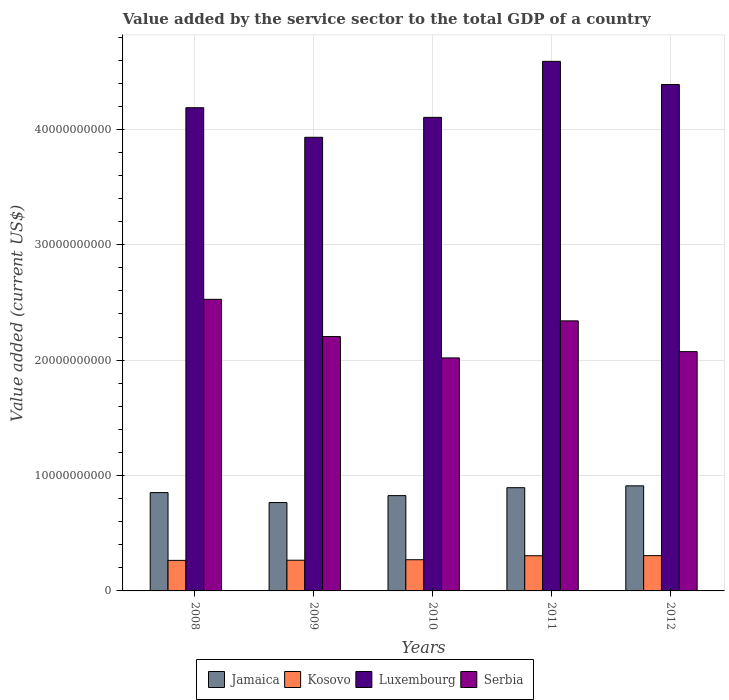How many different coloured bars are there?
Ensure brevity in your answer.  4. How many groups of bars are there?
Provide a short and direct response. 5. Are the number of bars per tick equal to the number of legend labels?
Make the answer very short. Yes. Are the number of bars on each tick of the X-axis equal?
Make the answer very short. Yes. In how many cases, is the number of bars for a given year not equal to the number of legend labels?
Provide a short and direct response. 0. What is the value added by the service sector to the total GDP in Kosovo in 2011?
Your response must be concise. 3.05e+09. Across all years, what is the maximum value added by the service sector to the total GDP in Kosovo?
Keep it short and to the point. 3.06e+09. Across all years, what is the minimum value added by the service sector to the total GDP in Serbia?
Provide a short and direct response. 2.02e+1. In which year was the value added by the service sector to the total GDP in Kosovo maximum?
Your answer should be very brief. 2012. What is the total value added by the service sector to the total GDP in Serbia in the graph?
Give a very brief answer. 1.12e+11. What is the difference between the value added by the service sector to the total GDP in Jamaica in 2009 and that in 2011?
Offer a very short reply. -1.29e+09. What is the difference between the value added by the service sector to the total GDP in Serbia in 2010 and the value added by the service sector to the total GDP in Kosovo in 2012?
Provide a succinct answer. 1.71e+1. What is the average value added by the service sector to the total GDP in Kosovo per year?
Give a very brief answer. 2.82e+09. In the year 2012, what is the difference between the value added by the service sector to the total GDP in Kosovo and value added by the service sector to the total GDP in Jamaica?
Provide a succinct answer. -6.05e+09. In how many years, is the value added by the service sector to the total GDP in Serbia greater than 10000000000 US$?
Make the answer very short. 5. What is the ratio of the value added by the service sector to the total GDP in Jamaica in 2008 to that in 2012?
Make the answer very short. 0.94. Is the difference between the value added by the service sector to the total GDP in Kosovo in 2010 and 2011 greater than the difference between the value added by the service sector to the total GDP in Jamaica in 2010 and 2011?
Provide a succinct answer. Yes. What is the difference between the highest and the second highest value added by the service sector to the total GDP in Luxembourg?
Offer a terse response. 2.01e+09. What is the difference between the highest and the lowest value added by the service sector to the total GDP in Jamaica?
Your answer should be very brief. 1.45e+09. In how many years, is the value added by the service sector to the total GDP in Luxembourg greater than the average value added by the service sector to the total GDP in Luxembourg taken over all years?
Ensure brevity in your answer.  2. Is the sum of the value added by the service sector to the total GDP in Serbia in 2008 and 2010 greater than the maximum value added by the service sector to the total GDP in Kosovo across all years?
Your response must be concise. Yes. What does the 1st bar from the left in 2011 represents?
Offer a very short reply. Jamaica. What does the 4th bar from the right in 2009 represents?
Offer a terse response. Jamaica. How many bars are there?
Provide a succinct answer. 20. Are all the bars in the graph horizontal?
Offer a terse response. No. What is the difference between two consecutive major ticks on the Y-axis?
Offer a terse response. 1.00e+1. Are the values on the major ticks of Y-axis written in scientific E-notation?
Give a very brief answer. No. Does the graph contain any zero values?
Ensure brevity in your answer.  No. How many legend labels are there?
Give a very brief answer. 4. How are the legend labels stacked?
Your answer should be compact. Horizontal. What is the title of the graph?
Give a very brief answer. Value added by the service sector to the total GDP of a country. What is the label or title of the X-axis?
Keep it short and to the point. Years. What is the label or title of the Y-axis?
Your answer should be compact. Value added (current US$). What is the Value added (current US$) of Jamaica in 2008?
Offer a terse response. 8.52e+09. What is the Value added (current US$) of Kosovo in 2008?
Provide a short and direct response. 2.65e+09. What is the Value added (current US$) in Luxembourg in 2008?
Offer a terse response. 4.19e+1. What is the Value added (current US$) of Serbia in 2008?
Give a very brief answer. 2.53e+1. What is the Value added (current US$) of Jamaica in 2009?
Your answer should be very brief. 7.66e+09. What is the Value added (current US$) in Kosovo in 2009?
Offer a very short reply. 2.66e+09. What is the Value added (current US$) of Luxembourg in 2009?
Offer a terse response. 3.93e+1. What is the Value added (current US$) of Serbia in 2009?
Offer a very short reply. 2.20e+1. What is the Value added (current US$) in Jamaica in 2010?
Offer a very short reply. 8.26e+09. What is the Value added (current US$) of Kosovo in 2010?
Offer a very short reply. 2.70e+09. What is the Value added (current US$) of Luxembourg in 2010?
Keep it short and to the point. 4.10e+1. What is the Value added (current US$) of Serbia in 2010?
Give a very brief answer. 2.02e+1. What is the Value added (current US$) of Jamaica in 2011?
Your response must be concise. 8.95e+09. What is the Value added (current US$) of Kosovo in 2011?
Ensure brevity in your answer.  3.05e+09. What is the Value added (current US$) in Luxembourg in 2011?
Give a very brief answer. 4.59e+1. What is the Value added (current US$) in Serbia in 2011?
Give a very brief answer. 2.34e+1. What is the Value added (current US$) in Jamaica in 2012?
Keep it short and to the point. 9.11e+09. What is the Value added (current US$) of Kosovo in 2012?
Keep it short and to the point. 3.06e+09. What is the Value added (current US$) in Luxembourg in 2012?
Your response must be concise. 4.39e+1. What is the Value added (current US$) in Serbia in 2012?
Your response must be concise. 2.07e+1. Across all years, what is the maximum Value added (current US$) in Jamaica?
Ensure brevity in your answer.  9.11e+09. Across all years, what is the maximum Value added (current US$) in Kosovo?
Provide a short and direct response. 3.06e+09. Across all years, what is the maximum Value added (current US$) in Luxembourg?
Your answer should be compact. 4.59e+1. Across all years, what is the maximum Value added (current US$) in Serbia?
Keep it short and to the point. 2.53e+1. Across all years, what is the minimum Value added (current US$) of Jamaica?
Provide a short and direct response. 7.66e+09. Across all years, what is the minimum Value added (current US$) of Kosovo?
Provide a short and direct response. 2.65e+09. Across all years, what is the minimum Value added (current US$) in Luxembourg?
Your response must be concise. 3.93e+1. Across all years, what is the minimum Value added (current US$) of Serbia?
Offer a terse response. 2.02e+1. What is the total Value added (current US$) in Jamaica in the graph?
Give a very brief answer. 4.25e+1. What is the total Value added (current US$) of Kosovo in the graph?
Ensure brevity in your answer.  1.41e+1. What is the total Value added (current US$) in Luxembourg in the graph?
Provide a succinct answer. 2.12e+11. What is the total Value added (current US$) of Serbia in the graph?
Your response must be concise. 1.12e+11. What is the difference between the Value added (current US$) in Jamaica in 2008 and that in 2009?
Your answer should be compact. 8.63e+08. What is the difference between the Value added (current US$) of Kosovo in 2008 and that in 2009?
Make the answer very short. -1.31e+07. What is the difference between the Value added (current US$) in Luxembourg in 2008 and that in 2009?
Your answer should be compact. 2.56e+09. What is the difference between the Value added (current US$) of Serbia in 2008 and that in 2009?
Your answer should be very brief. 3.23e+09. What is the difference between the Value added (current US$) in Jamaica in 2008 and that in 2010?
Make the answer very short. 2.62e+08. What is the difference between the Value added (current US$) of Kosovo in 2008 and that in 2010?
Your answer should be very brief. -5.67e+07. What is the difference between the Value added (current US$) in Luxembourg in 2008 and that in 2010?
Offer a terse response. 8.35e+08. What is the difference between the Value added (current US$) in Serbia in 2008 and that in 2010?
Offer a very short reply. 5.08e+09. What is the difference between the Value added (current US$) in Jamaica in 2008 and that in 2011?
Your answer should be compact. -4.25e+08. What is the difference between the Value added (current US$) in Kosovo in 2008 and that in 2011?
Keep it short and to the point. -4.02e+08. What is the difference between the Value added (current US$) of Luxembourg in 2008 and that in 2011?
Your response must be concise. -4.02e+09. What is the difference between the Value added (current US$) of Serbia in 2008 and that in 2011?
Your answer should be compact. 1.87e+09. What is the difference between the Value added (current US$) in Jamaica in 2008 and that in 2012?
Keep it short and to the point. -5.87e+08. What is the difference between the Value added (current US$) in Kosovo in 2008 and that in 2012?
Provide a short and direct response. -4.11e+08. What is the difference between the Value added (current US$) of Luxembourg in 2008 and that in 2012?
Offer a terse response. -2.01e+09. What is the difference between the Value added (current US$) of Serbia in 2008 and that in 2012?
Make the answer very short. 4.53e+09. What is the difference between the Value added (current US$) in Jamaica in 2009 and that in 2010?
Provide a succinct answer. -6.01e+08. What is the difference between the Value added (current US$) of Kosovo in 2009 and that in 2010?
Offer a terse response. -4.37e+07. What is the difference between the Value added (current US$) in Luxembourg in 2009 and that in 2010?
Offer a terse response. -1.73e+09. What is the difference between the Value added (current US$) of Serbia in 2009 and that in 2010?
Provide a short and direct response. 1.85e+09. What is the difference between the Value added (current US$) in Jamaica in 2009 and that in 2011?
Your answer should be compact. -1.29e+09. What is the difference between the Value added (current US$) in Kosovo in 2009 and that in 2011?
Give a very brief answer. -3.88e+08. What is the difference between the Value added (current US$) of Luxembourg in 2009 and that in 2011?
Your answer should be very brief. -6.58e+09. What is the difference between the Value added (current US$) in Serbia in 2009 and that in 2011?
Your answer should be very brief. -1.36e+09. What is the difference between the Value added (current US$) in Jamaica in 2009 and that in 2012?
Provide a short and direct response. -1.45e+09. What is the difference between the Value added (current US$) in Kosovo in 2009 and that in 2012?
Provide a succinct answer. -3.98e+08. What is the difference between the Value added (current US$) in Luxembourg in 2009 and that in 2012?
Your answer should be compact. -4.57e+09. What is the difference between the Value added (current US$) of Serbia in 2009 and that in 2012?
Provide a succinct answer. 1.30e+09. What is the difference between the Value added (current US$) in Jamaica in 2010 and that in 2011?
Offer a terse response. -6.86e+08. What is the difference between the Value added (current US$) in Kosovo in 2010 and that in 2011?
Offer a terse response. -3.45e+08. What is the difference between the Value added (current US$) of Luxembourg in 2010 and that in 2011?
Your answer should be very brief. -4.85e+09. What is the difference between the Value added (current US$) of Serbia in 2010 and that in 2011?
Keep it short and to the point. -3.21e+09. What is the difference between the Value added (current US$) of Jamaica in 2010 and that in 2012?
Your answer should be compact. -8.49e+08. What is the difference between the Value added (current US$) in Kosovo in 2010 and that in 2012?
Offer a very short reply. -3.54e+08. What is the difference between the Value added (current US$) in Luxembourg in 2010 and that in 2012?
Your response must be concise. -2.85e+09. What is the difference between the Value added (current US$) in Serbia in 2010 and that in 2012?
Keep it short and to the point. -5.45e+08. What is the difference between the Value added (current US$) of Jamaica in 2011 and that in 2012?
Your response must be concise. -1.62e+08. What is the difference between the Value added (current US$) of Kosovo in 2011 and that in 2012?
Make the answer very short. -9.57e+06. What is the difference between the Value added (current US$) of Luxembourg in 2011 and that in 2012?
Keep it short and to the point. 2.01e+09. What is the difference between the Value added (current US$) in Serbia in 2011 and that in 2012?
Provide a short and direct response. 2.67e+09. What is the difference between the Value added (current US$) of Jamaica in 2008 and the Value added (current US$) of Kosovo in 2009?
Ensure brevity in your answer.  5.86e+09. What is the difference between the Value added (current US$) of Jamaica in 2008 and the Value added (current US$) of Luxembourg in 2009?
Provide a short and direct response. -3.08e+1. What is the difference between the Value added (current US$) in Jamaica in 2008 and the Value added (current US$) in Serbia in 2009?
Provide a succinct answer. -1.35e+1. What is the difference between the Value added (current US$) of Kosovo in 2008 and the Value added (current US$) of Luxembourg in 2009?
Ensure brevity in your answer.  -3.67e+1. What is the difference between the Value added (current US$) in Kosovo in 2008 and the Value added (current US$) in Serbia in 2009?
Make the answer very short. -1.94e+1. What is the difference between the Value added (current US$) of Luxembourg in 2008 and the Value added (current US$) of Serbia in 2009?
Your response must be concise. 1.98e+1. What is the difference between the Value added (current US$) of Jamaica in 2008 and the Value added (current US$) of Kosovo in 2010?
Your answer should be compact. 5.82e+09. What is the difference between the Value added (current US$) in Jamaica in 2008 and the Value added (current US$) in Luxembourg in 2010?
Provide a succinct answer. -3.25e+1. What is the difference between the Value added (current US$) in Jamaica in 2008 and the Value added (current US$) in Serbia in 2010?
Ensure brevity in your answer.  -1.17e+1. What is the difference between the Value added (current US$) of Kosovo in 2008 and the Value added (current US$) of Luxembourg in 2010?
Offer a terse response. -3.84e+1. What is the difference between the Value added (current US$) in Kosovo in 2008 and the Value added (current US$) in Serbia in 2010?
Your answer should be compact. -1.75e+1. What is the difference between the Value added (current US$) in Luxembourg in 2008 and the Value added (current US$) in Serbia in 2010?
Ensure brevity in your answer.  2.17e+1. What is the difference between the Value added (current US$) of Jamaica in 2008 and the Value added (current US$) of Kosovo in 2011?
Give a very brief answer. 5.47e+09. What is the difference between the Value added (current US$) of Jamaica in 2008 and the Value added (current US$) of Luxembourg in 2011?
Your answer should be very brief. -3.74e+1. What is the difference between the Value added (current US$) of Jamaica in 2008 and the Value added (current US$) of Serbia in 2011?
Offer a very short reply. -1.49e+1. What is the difference between the Value added (current US$) in Kosovo in 2008 and the Value added (current US$) in Luxembourg in 2011?
Offer a very short reply. -4.32e+1. What is the difference between the Value added (current US$) in Kosovo in 2008 and the Value added (current US$) in Serbia in 2011?
Offer a terse response. -2.08e+1. What is the difference between the Value added (current US$) in Luxembourg in 2008 and the Value added (current US$) in Serbia in 2011?
Your answer should be compact. 1.85e+1. What is the difference between the Value added (current US$) of Jamaica in 2008 and the Value added (current US$) of Kosovo in 2012?
Offer a terse response. 5.46e+09. What is the difference between the Value added (current US$) of Jamaica in 2008 and the Value added (current US$) of Luxembourg in 2012?
Give a very brief answer. -3.54e+1. What is the difference between the Value added (current US$) of Jamaica in 2008 and the Value added (current US$) of Serbia in 2012?
Make the answer very short. -1.22e+1. What is the difference between the Value added (current US$) of Kosovo in 2008 and the Value added (current US$) of Luxembourg in 2012?
Give a very brief answer. -4.12e+1. What is the difference between the Value added (current US$) of Kosovo in 2008 and the Value added (current US$) of Serbia in 2012?
Give a very brief answer. -1.81e+1. What is the difference between the Value added (current US$) of Luxembourg in 2008 and the Value added (current US$) of Serbia in 2012?
Your response must be concise. 2.11e+1. What is the difference between the Value added (current US$) in Jamaica in 2009 and the Value added (current US$) in Kosovo in 2010?
Ensure brevity in your answer.  4.95e+09. What is the difference between the Value added (current US$) in Jamaica in 2009 and the Value added (current US$) in Luxembourg in 2010?
Offer a terse response. -3.34e+1. What is the difference between the Value added (current US$) of Jamaica in 2009 and the Value added (current US$) of Serbia in 2010?
Offer a very short reply. -1.25e+1. What is the difference between the Value added (current US$) in Kosovo in 2009 and the Value added (current US$) in Luxembourg in 2010?
Keep it short and to the point. -3.84e+1. What is the difference between the Value added (current US$) of Kosovo in 2009 and the Value added (current US$) of Serbia in 2010?
Provide a short and direct response. -1.75e+1. What is the difference between the Value added (current US$) in Luxembourg in 2009 and the Value added (current US$) in Serbia in 2010?
Make the answer very short. 1.91e+1. What is the difference between the Value added (current US$) of Jamaica in 2009 and the Value added (current US$) of Kosovo in 2011?
Your response must be concise. 4.61e+09. What is the difference between the Value added (current US$) in Jamaica in 2009 and the Value added (current US$) in Luxembourg in 2011?
Keep it short and to the point. -3.82e+1. What is the difference between the Value added (current US$) in Jamaica in 2009 and the Value added (current US$) in Serbia in 2011?
Your answer should be compact. -1.57e+1. What is the difference between the Value added (current US$) of Kosovo in 2009 and the Value added (current US$) of Luxembourg in 2011?
Give a very brief answer. -4.32e+1. What is the difference between the Value added (current US$) of Kosovo in 2009 and the Value added (current US$) of Serbia in 2011?
Ensure brevity in your answer.  -2.07e+1. What is the difference between the Value added (current US$) in Luxembourg in 2009 and the Value added (current US$) in Serbia in 2011?
Keep it short and to the point. 1.59e+1. What is the difference between the Value added (current US$) of Jamaica in 2009 and the Value added (current US$) of Kosovo in 2012?
Keep it short and to the point. 4.60e+09. What is the difference between the Value added (current US$) of Jamaica in 2009 and the Value added (current US$) of Luxembourg in 2012?
Your answer should be very brief. -3.62e+1. What is the difference between the Value added (current US$) of Jamaica in 2009 and the Value added (current US$) of Serbia in 2012?
Offer a very short reply. -1.31e+1. What is the difference between the Value added (current US$) in Kosovo in 2009 and the Value added (current US$) in Luxembourg in 2012?
Your answer should be compact. -4.12e+1. What is the difference between the Value added (current US$) of Kosovo in 2009 and the Value added (current US$) of Serbia in 2012?
Make the answer very short. -1.81e+1. What is the difference between the Value added (current US$) of Luxembourg in 2009 and the Value added (current US$) of Serbia in 2012?
Give a very brief answer. 1.86e+1. What is the difference between the Value added (current US$) in Jamaica in 2010 and the Value added (current US$) in Kosovo in 2011?
Your answer should be compact. 5.21e+09. What is the difference between the Value added (current US$) in Jamaica in 2010 and the Value added (current US$) in Luxembourg in 2011?
Keep it short and to the point. -3.76e+1. What is the difference between the Value added (current US$) in Jamaica in 2010 and the Value added (current US$) in Serbia in 2011?
Ensure brevity in your answer.  -1.51e+1. What is the difference between the Value added (current US$) in Kosovo in 2010 and the Value added (current US$) in Luxembourg in 2011?
Your answer should be compact. -4.32e+1. What is the difference between the Value added (current US$) in Kosovo in 2010 and the Value added (current US$) in Serbia in 2011?
Provide a succinct answer. -2.07e+1. What is the difference between the Value added (current US$) of Luxembourg in 2010 and the Value added (current US$) of Serbia in 2011?
Your answer should be compact. 1.76e+1. What is the difference between the Value added (current US$) in Jamaica in 2010 and the Value added (current US$) in Kosovo in 2012?
Your response must be concise. 5.20e+09. What is the difference between the Value added (current US$) of Jamaica in 2010 and the Value added (current US$) of Luxembourg in 2012?
Your response must be concise. -3.56e+1. What is the difference between the Value added (current US$) in Jamaica in 2010 and the Value added (current US$) in Serbia in 2012?
Your response must be concise. -1.25e+1. What is the difference between the Value added (current US$) in Kosovo in 2010 and the Value added (current US$) in Luxembourg in 2012?
Give a very brief answer. -4.12e+1. What is the difference between the Value added (current US$) of Kosovo in 2010 and the Value added (current US$) of Serbia in 2012?
Your answer should be very brief. -1.80e+1. What is the difference between the Value added (current US$) in Luxembourg in 2010 and the Value added (current US$) in Serbia in 2012?
Give a very brief answer. 2.03e+1. What is the difference between the Value added (current US$) in Jamaica in 2011 and the Value added (current US$) in Kosovo in 2012?
Provide a succinct answer. 5.89e+09. What is the difference between the Value added (current US$) in Jamaica in 2011 and the Value added (current US$) in Luxembourg in 2012?
Make the answer very short. -3.49e+1. What is the difference between the Value added (current US$) in Jamaica in 2011 and the Value added (current US$) in Serbia in 2012?
Offer a very short reply. -1.18e+1. What is the difference between the Value added (current US$) of Kosovo in 2011 and the Value added (current US$) of Luxembourg in 2012?
Ensure brevity in your answer.  -4.08e+1. What is the difference between the Value added (current US$) in Kosovo in 2011 and the Value added (current US$) in Serbia in 2012?
Ensure brevity in your answer.  -1.77e+1. What is the difference between the Value added (current US$) in Luxembourg in 2011 and the Value added (current US$) in Serbia in 2012?
Your response must be concise. 2.52e+1. What is the average Value added (current US$) in Jamaica per year?
Provide a short and direct response. 8.50e+09. What is the average Value added (current US$) in Kosovo per year?
Provide a succinct answer. 2.82e+09. What is the average Value added (current US$) in Luxembourg per year?
Give a very brief answer. 4.24e+1. What is the average Value added (current US$) of Serbia per year?
Your response must be concise. 2.23e+1. In the year 2008, what is the difference between the Value added (current US$) in Jamaica and Value added (current US$) in Kosovo?
Give a very brief answer. 5.87e+09. In the year 2008, what is the difference between the Value added (current US$) of Jamaica and Value added (current US$) of Luxembourg?
Provide a short and direct response. -3.34e+1. In the year 2008, what is the difference between the Value added (current US$) in Jamaica and Value added (current US$) in Serbia?
Provide a short and direct response. -1.67e+1. In the year 2008, what is the difference between the Value added (current US$) in Kosovo and Value added (current US$) in Luxembourg?
Your answer should be very brief. -3.92e+1. In the year 2008, what is the difference between the Value added (current US$) of Kosovo and Value added (current US$) of Serbia?
Your answer should be very brief. -2.26e+1. In the year 2008, what is the difference between the Value added (current US$) of Luxembourg and Value added (current US$) of Serbia?
Ensure brevity in your answer.  1.66e+1. In the year 2009, what is the difference between the Value added (current US$) of Jamaica and Value added (current US$) of Kosovo?
Your answer should be very brief. 5.00e+09. In the year 2009, what is the difference between the Value added (current US$) in Jamaica and Value added (current US$) in Luxembourg?
Keep it short and to the point. -3.17e+1. In the year 2009, what is the difference between the Value added (current US$) in Jamaica and Value added (current US$) in Serbia?
Make the answer very short. -1.44e+1. In the year 2009, what is the difference between the Value added (current US$) in Kosovo and Value added (current US$) in Luxembourg?
Ensure brevity in your answer.  -3.67e+1. In the year 2009, what is the difference between the Value added (current US$) in Kosovo and Value added (current US$) in Serbia?
Your answer should be very brief. -1.94e+1. In the year 2009, what is the difference between the Value added (current US$) in Luxembourg and Value added (current US$) in Serbia?
Your answer should be very brief. 1.73e+1. In the year 2010, what is the difference between the Value added (current US$) in Jamaica and Value added (current US$) in Kosovo?
Give a very brief answer. 5.56e+09. In the year 2010, what is the difference between the Value added (current US$) in Jamaica and Value added (current US$) in Luxembourg?
Your answer should be very brief. -3.28e+1. In the year 2010, what is the difference between the Value added (current US$) in Jamaica and Value added (current US$) in Serbia?
Provide a succinct answer. -1.19e+1. In the year 2010, what is the difference between the Value added (current US$) in Kosovo and Value added (current US$) in Luxembourg?
Your response must be concise. -3.83e+1. In the year 2010, what is the difference between the Value added (current US$) of Kosovo and Value added (current US$) of Serbia?
Offer a terse response. -1.75e+1. In the year 2010, what is the difference between the Value added (current US$) in Luxembourg and Value added (current US$) in Serbia?
Ensure brevity in your answer.  2.08e+1. In the year 2011, what is the difference between the Value added (current US$) in Jamaica and Value added (current US$) in Kosovo?
Give a very brief answer. 5.90e+09. In the year 2011, what is the difference between the Value added (current US$) in Jamaica and Value added (current US$) in Luxembourg?
Give a very brief answer. -3.69e+1. In the year 2011, what is the difference between the Value added (current US$) of Jamaica and Value added (current US$) of Serbia?
Offer a very short reply. -1.45e+1. In the year 2011, what is the difference between the Value added (current US$) in Kosovo and Value added (current US$) in Luxembourg?
Your response must be concise. -4.28e+1. In the year 2011, what is the difference between the Value added (current US$) in Kosovo and Value added (current US$) in Serbia?
Make the answer very short. -2.04e+1. In the year 2011, what is the difference between the Value added (current US$) in Luxembourg and Value added (current US$) in Serbia?
Offer a terse response. 2.25e+1. In the year 2012, what is the difference between the Value added (current US$) of Jamaica and Value added (current US$) of Kosovo?
Keep it short and to the point. 6.05e+09. In the year 2012, what is the difference between the Value added (current US$) of Jamaica and Value added (current US$) of Luxembourg?
Your answer should be compact. -3.48e+1. In the year 2012, what is the difference between the Value added (current US$) of Jamaica and Value added (current US$) of Serbia?
Ensure brevity in your answer.  -1.16e+1. In the year 2012, what is the difference between the Value added (current US$) of Kosovo and Value added (current US$) of Luxembourg?
Your answer should be very brief. -4.08e+1. In the year 2012, what is the difference between the Value added (current US$) of Kosovo and Value added (current US$) of Serbia?
Keep it short and to the point. -1.77e+1. In the year 2012, what is the difference between the Value added (current US$) of Luxembourg and Value added (current US$) of Serbia?
Ensure brevity in your answer.  2.31e+1. What is the ratio of the Value added (current US$) of Jamaica in 2008 to that in 2009?
Your response must be concise. 1.11. What is the ratio of the Value added (current US$) in Kosovo in 2008 to that in 2009?
Your answer should be very brief. 1. What is the ratio of the Value added (current US$) in Luxembourg in 2008 to that in 2009?
Give a very brief answer. 1.07. What is the ratio of the Value added (current US$) of Serbia in 2008 to that in 2009?
Your response must be concise. 1.15. What is the ratio of the Value added (current US$) of Jamaica in 2008 to that in 2010?
Provide a short and direct response. 1.03. What is the ratio of the Value added (current US$) of Luxembourg in 2008 to that in 2010?
Your response must be concise. 1.02. What is the ratio of the Value added (current US$) of Serbia in 2008 to that in 2010?
Give a very brief answer. 1.25. What is the ratio of the Value added (current US$) of Jamaica in 2008 to that in 2011?
Provide a short and direct response. 0.95. What is the ratio of the Value added (current US$) of Kosovo in 2008 to that in 2011?
Your answer should be compact. 0.87. What is the ratio of the Value added (current US$) in Luxembourg in 2008 to that in 2011?
Provide a succinct answer. 0.91. What is the ratio of the Value added (current US$) of Serbia in 2008 to that in 2011?
Provide a succinct answer. 1.08. What is the ratio of the Value added (current US$) of Jamaica in 2008 to that in 2012?
Provide a short and direct response. 0.94. What is the ratio of the Value added (current US$) in Kosovo in 2008 to that in 2012?
Ensure brevity in your answer.  0.87. What is the ratio of the Value added (current US$) in Luxembourg in 2008 to that in 2012?
Your response must be concise. 0.95. What is the ratio of the Value added (current US$) in Serbia in 2008 to that in 2012?
Ensure brevity in your answer.  1.22. What is the ratio of the Value added (current US$) of Jamaica in 2009 to that in 2010?
Offer a very short reply. 0.93. What is the ratio of the Value added (current US$) of Kosovo in 2009 to that in 2010?
Offer a terse response. 0.98. What is the ratio of the Value added (current US$) in Luxembourg in 2009 to that in 2010?
Your response must be concise. 0.96. What is the ratio of the Value added (current US$) in Serbia in 2009 to that in 2010?
Give a very brief answer. 1.09. What is the ratio of the Value added (current US$) in Jamaica in 2009 to that in 2011?
Your response must be concise. 0.86. What is the ratio of the Value added (current US$) of Kosovo in 2009 to that in 2011?
Your response must be concise. 0.87. What is the ratio of the Value added (current US$) of Luxembourg in 2009 to that in 2011?
Offer a terse response. 0.86. What is the ratio of the Value added (current US$) in Serbia in 2009 to that in 2011?
Ensure brevity in your answer.  0.94. What is the ratio of the Value added (current US$) in Jamaica in 2009 to that in 2012?
Offer a very short reply. 0.84. What is the ratio of the Value added (current US$) of Kosovo in 2009 to that in 2012?
Ensure brevity in your answer.  0.87. What is the ratio of the Value added (current US$) of Luxembourg in 2009 to that in 2012?
Your answer should be very brief. 0.9. What is the ratio of the Value added (current US$) of Serbia in 2009 to that in 2012?
Keep it short and to the point. 1.06. What is the ratio of the Value added (current US$) in Jamaica in 2010 to that in 2011?
Give a very brief answer. 0.92. What is the ratio of the Value added (current US$) in Kosovo in 2010 to that in 2011?
Keep it short and to the point. 0.89. What is the ratio of the Value added (current US$) of Luxembourg in 2010 to that in 2011?
Provide a short and direct response. 0.89. What is the ratio of the Value added (current US$) of Serbia in 2010 to that in 2011?
Your answer should be very brief. 0.86. What is the ratio of the Value added (current US$) in Jamaica in 2010 to that in 2012?
Your response must be concise. 0.91. What is the ratio of the Value added (current US$) of Kosovo in 2010 to that in 2012?
Your response must be concise. 0.88. What is the ratio of the Value added (current US$) of Luxembourg in 2010 to that in 2012?
Your answer should be compact. 0.94. What is the ratio of the Value added (current US$) in Serbia in 2010 to that in 2012?
Provide a succinct answer. 0.97. What is the ratio of the Value added (current US$) in Jamaica in 2011 to that in 2012?
Your answer should be very brief. 0.98. What is the ratio of the Value added (current US$) of Kosovo in 2011 to that in 2012?
Your answer should be compact. 1. What is the ratio of the Value added (current US$) in Luxembourg in 2011 to that in 2012?
Provide a short and direct response. 1.05. What is the ratio of the Value added (current US$) of Serbia in 2011 to that in 2012?
Ensure brevity in your answer.  1.13. What is the difference between the highest and the second highest Value added (current US$) in Jamaica?
Make the answer very short. 1.62e+08. What is the difference between the highest and the second highest Value added (current US$) in Kosovo?
Ensure brevity in your answer.  9.57e+06. What is the difference between the highest and the second highest Value added (current US$) of Luxembourg?
Your answer should be very brief. 2.01e+09. What is the difference between the highest and the second highest Value added (current US$) of Serbia?
Ensure brevity in your answer.  1.87e+09. What is the difference between the highest and the lowest Value added (current US$) in Jamaica?
Your response must be concise. 1.45e+09. What is the difference between the highest and the lowest Value added (current US$) in Kosovo?
Your response must be concise. 4.11e+08. What is the difference between the highest and the lowest Value added (current US$) in Luxembourg?
Provide a short and direct response. 6.58e+09. What is the difference between the highest and the lowest Value added (current US$) of Serbia?
Give a very brief answer. 5.08e+09. 